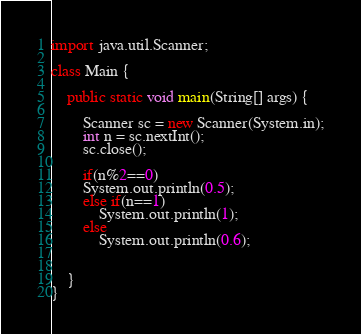Convert code to text. <code><loc_0><loc_0><loc_500><loc_500><_Java_>import java.util.Scanner;

class Main {

	public static void main(String[] args) {

		Scanner sc = new Scanner(System.in);
		int n = sc.nextInt();
		sc.close();

		if(n%2==0)
		System.out.println(0.5);
		else if(n==1)
			System.out.println(1);
		else
			System.out.println(0.6);


	}
}</code> 